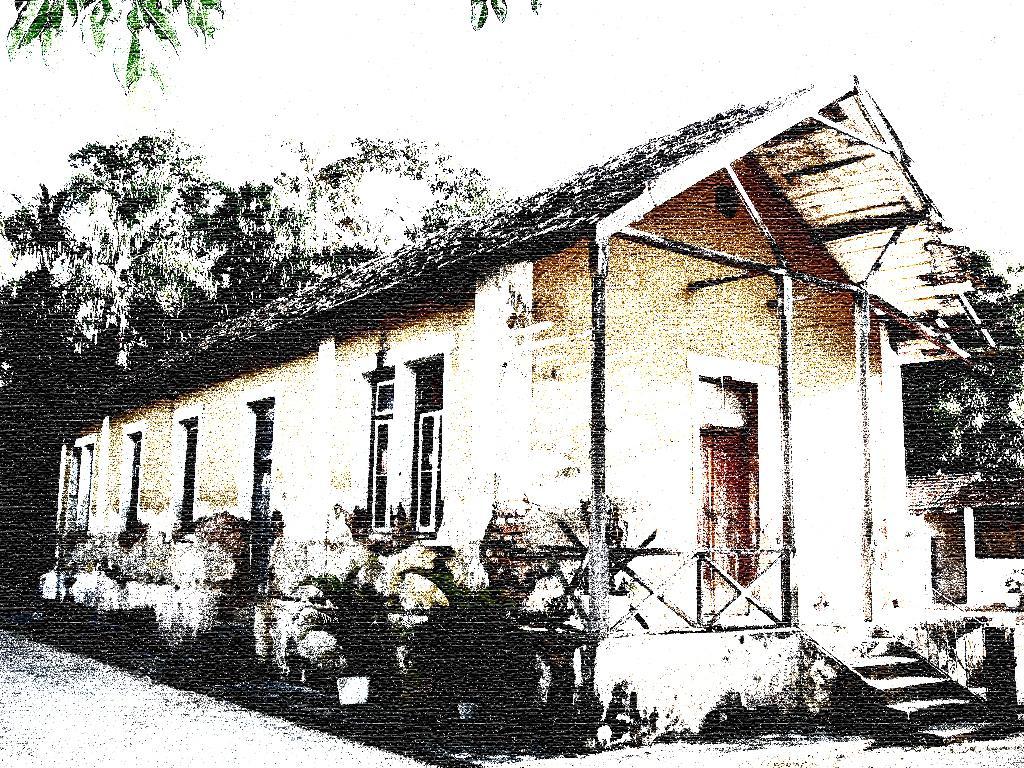Please provide a concise description of this image. In the center of the image we can see a house. On the left side of the house we can see plants. In the background there are trees and sky. 